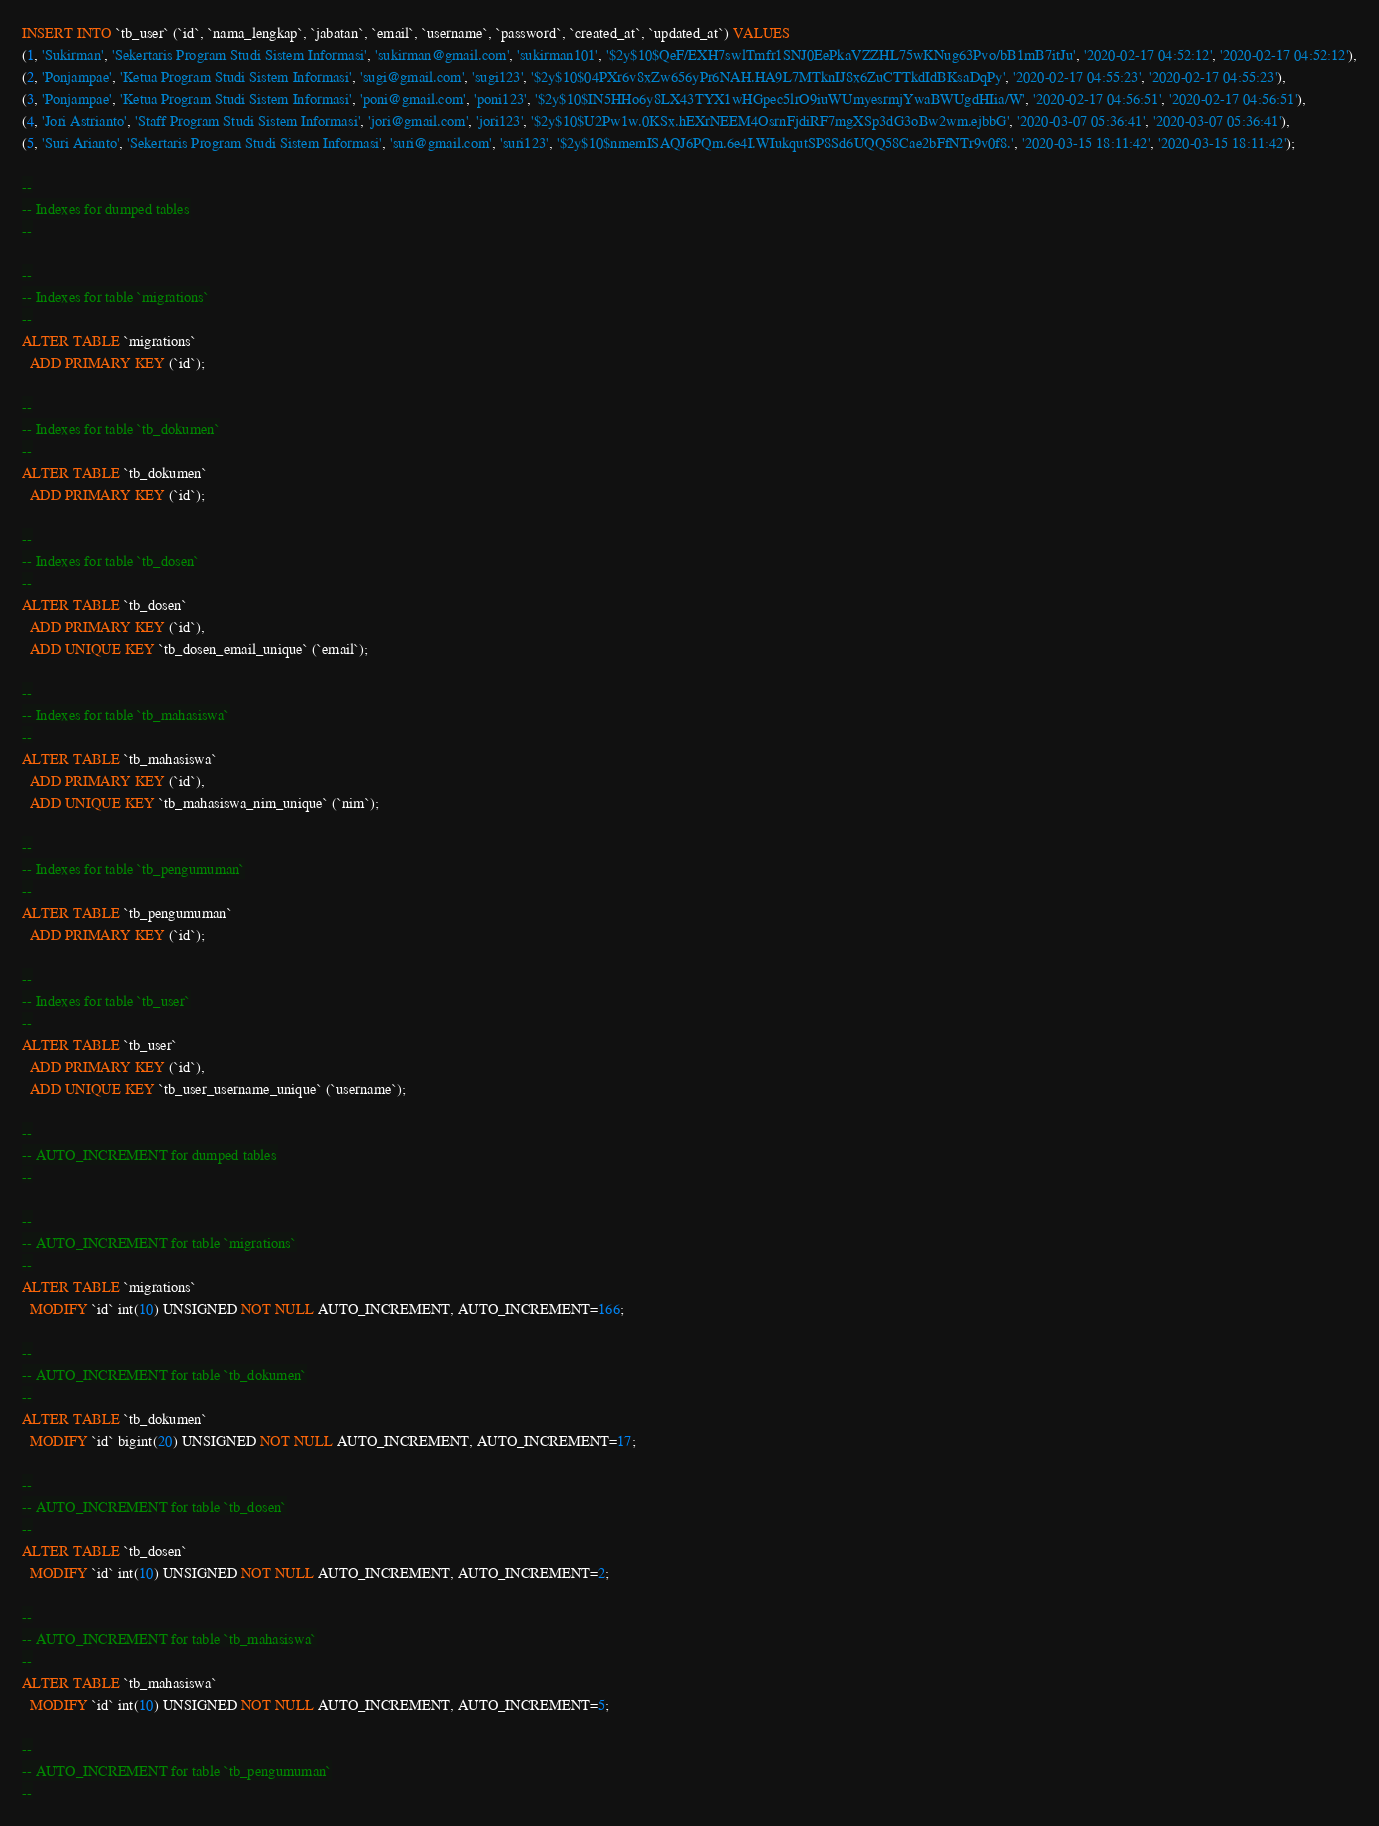Convert code to text. <code><loc_0><loc_0><loc_500><loc_500><_SQL_>
INSERT INTO `tb_user` (`id`, `nama_lengkap`, `jabatan`, `email`, `username`, `password`, `created_at`, `updated_at`) VALUES
(1, 'Sukirman', 'Sekertaris Program Studi Sistem Informasi', 'sukirman@gmail.com', 'sukirman101', '$2y$10$QeF/EXH7swlTmfr1SNJ0EePkaVZZHL75wKNug63Pvo/bB1mB7itJu', '2020-02-17 04:52:12', '2020-02-17 04:52:12'),
(2, 'Ponjampae', 'Ketua Program Studi Sistem Informasi', 'sugi@gmail.com', 'sugi123', '$2y$10$04PXr6v8xZw656yPr6NAH.HA9L7MTknIJ8x6ZuCTTkdIdBKsaDqPy', '2020-02-17 04:55:23', '2020-02-17 04:55:23'),
(3, 'Ponjampae', 'Ketua Program Studi Sistem Informasi', 'poni@gmail.com', 'poni123', '$2y$10$IN5HHo6y8LX43TYX1wHGpec5lrO9iuWUmyesrmjYwaBWUgdHIia/W', '2020-02-17 04:56:51', '2020-02-17 04:56:51'),
(4, 'Jori Astrianto', 'Staff Program Studi Sistem Informasi', 'jori@gmail.com', 'jori123', '$2y$10$U2Pw1w.0KSx.hEXrNEEM4OsrnFjdiRF7mgXSp3dG3oBw2wm.ejbbG', '2020-03-07 05:36:41', '2020-03-07 05:36:41'),
(5, 'Suri Arianto', 'Sekertaris Program Studi Sistem Informasi', 'suri@gmail.com', 'suri123', '$2y$10$nmemISAQJ6PQm.6e4I.WIukqutSP8Sd6UQQ58Cae2bFfNTr9v0f8.', '2020-03-15 18:11:42', '2020-03-15 18:11:42');

--
-- Indexes for dumped tables
--

--
-- Indexes for table `migrations`
--
ALTER TABLE `migrations`
  ADD PRIMARY KEY (`id`);

--
-- Indexes for table `tb_dokumen`
--
ALTER TABLE `tb_dokumen`
  ADD PRIMARY KEY (`id`);

--
-- Indexes for table `tb_dosen`
--
ALTER TABLE `tb_dosen`
  ADD PRIMARY KEY (`id`),
  ADD UNIQUE KEY `tb_dosen_email_unique` (`email`);

--
-- Indexes for table `tb_mahasiswa`
--
ALTER TABLE `tb_mahasiswa`
  ADD PRIMARY KEY (`id`),
  ADD UNIQUE KEY `tb_mahasiswa_nim_unique` (`nim`);

--
-- Indexes for table `tb_pengumuman`
--
ALTER TABLE `tb_pengumuman`
  ADD PRIMARY KEY (`id`);

--
-- Indexes for table `tb_user`
--
ALTER TABLE `tb_user`
  ADD PRIMARY KEY (`id`),
  ADD UNIQUE KEY `tb_user_username_unique` (`username`);

--
-- AUTO_INCREMENT for dumped tables
--

--
-- AUTO_INCREMENT for table `migrations`
--
ALTER TABLE `migrations`
  MODIFY `id` int(10) UNSIGNED NOT NULL AUTO_INCREMENT, AUTO_INCREMENT=166;

--
-- AUTO_INCREMENT for table `tb_dokumen`
--
ALTER TABLE `tb_dokumen`
  MODIFY `id` bigint(20) UNSIGNED NOT NULL AUTO_INCREMENT, AUTO_INCREMENT=17;

--
-- AUTO_INCREMENT for table `tb_dosen`
--
ALTER TABLE `tb_dosen`
  MODIFY `id` int(10) UNSIGNED NOT NULL AUTO_INCREMENT, AUTO_INCREMENT=2;

--
-- AUTO_INCREMENT for table `tb_mahasiswa`
--
ALTER TABLE `tb_mahasiswa`
  MODIFY `id` int(10) UNSIGNED NOT NULL AUTO_INCREMENT, AUTO_INCREMENT=5;

--
-- AUTO_INCREMENT for table `tb_pengumuman`
--</code> 